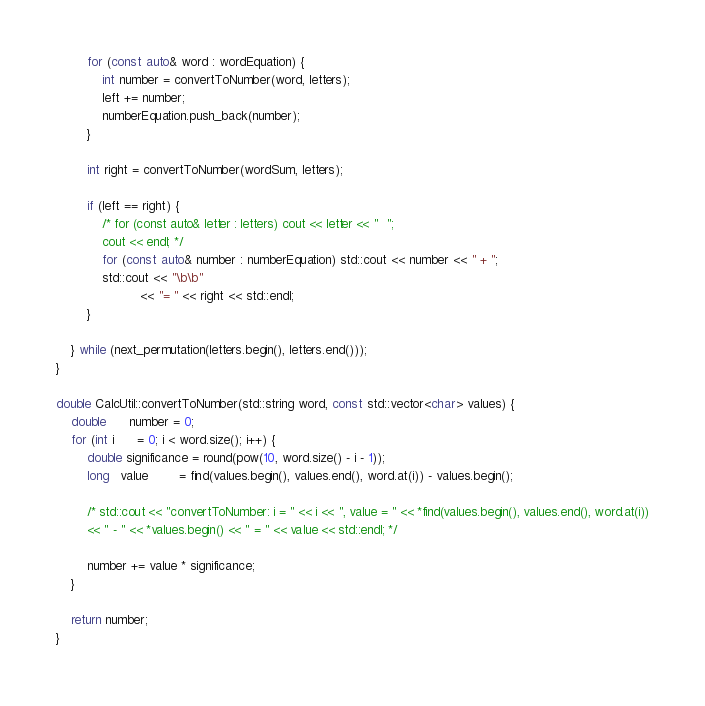<code> <loc_0><loc_0><loc_500><loc_500><_C++_>
        for (const auto& word : wordEquation) {
            int number = convertToNumber(word, letters);
            left += number;
            numberEquation.push_back(number);
        }

        int right = convertToNumber(wordSum, letters);

        if (left == right) {
            /* for (const auto& letter : letters) cout << letter << "  ";
            cout << endl; */
            for (const auto& number : numberEquation) std::cout << number << " + ";
            std::cout << "\b\b"
                      << "= " << right << std::endl;
        }

    } while (next_permutation(letters.begin(), letters.end()));
}

double CalcUtil::convertToNumber(std::string word, const std::vector<char> values) {
    double      number = 0;
    for (int i      = 0; i < word.size(); i++) {
        double significance = round(pow(10, word.size() - i - 1));
        long   value        = find(values.begin(), values.end(), word.at(i)) - values.begin();

        /* std::cout << "convertToNumber: i = " << i << ", value = " << *find(values.begin(), values.end(), word.at(i))
        << " - " << *values.begin() << " = " << value << std::endl; */

        number += value * significance;
    }

    return number;
}</code> 